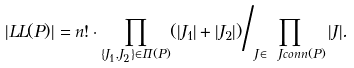Convert formula to latex. <formula><loc_0><loc_0><loc_500><loc_500>| \L L L ( P ) | = n ! \cdot { \prod _ { \{ J _ { 1 } , J _ { 2 } \} \in \Pi ( P ) } ( | J _ { 1 } | + | J _ { 2 } | ) } \Big / { \prod _ { J \in \ J c o n n ( P ) } | J | } .</formula> 